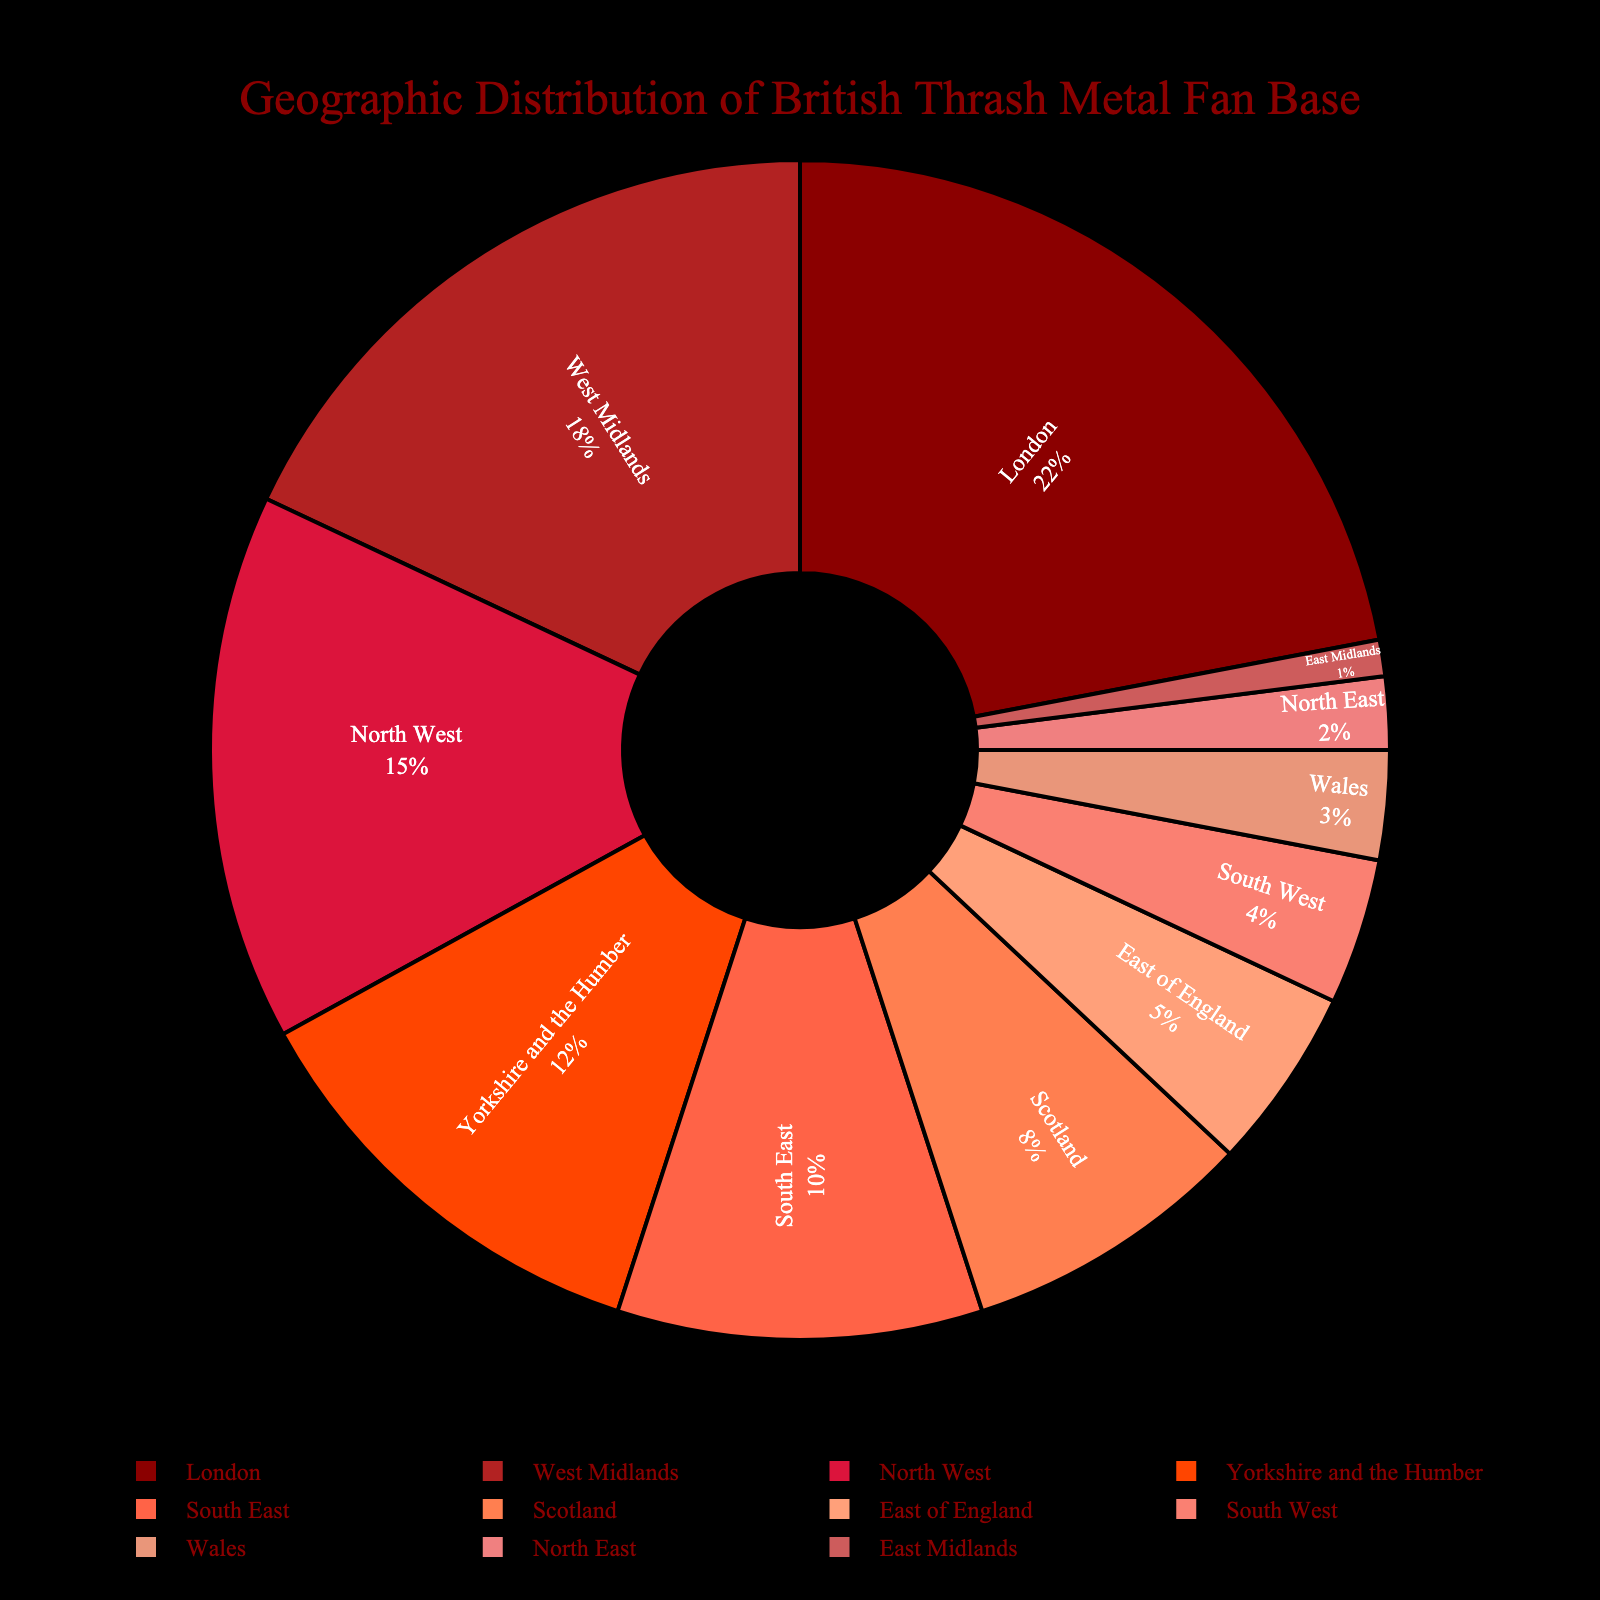What is the region with the highest percentage of British Thrash Metal fans? The region with the highest percentage can be identified directly by looking for the largest segment in the pie chart. London has the biggest slice, indicating it has the highest percentage at 22%.
Answer: London Which two regions combined make up the largest percentage of the fan base? To find the combination that forms the largest percentage, identify the two largest slices in the pie chart. London (22%) and West Midlands (18%) have the biggest slices, summing up to 40%.
Answer: London and West Midlands How many regions have a fan base percentage of 10% or higher? By counting the slices that represent 10% or more, we have London (22%), West Midlands (18%), North West (15%), and Yorkshire and the Humber (12%). This sums to four regions.
Answer: Four What is the difference in fan base percentages between the region with the highest percentage and the region with the lowest percentage? The highest percentage is London at 22%, and the lowest is East Midlands at 1%. The difference is calculated as 22% - 1% = 21%.
Answer: 21% Name the regions that make up more than 15% of the fan base combined. Summarizing the relevant data: West Midlands (18%), North West (15%), and Yorkshire and the Humber (12%) each contribute less than 15% separately. London (22%) is the sole region surpassing this threshold.
Answer: London Which region contributes the smallest slice to the fan base, and what is its percentage? The smallest slice is the East Midlands, which has the smallest visible segment in the pie chart at 1%.
Answer: East Midlands Are there more regions with less than 5% fan base, or more than 5% fan base? Comparing the number of regions:
- Less than 5%: East of England (5%), South West (4%), Wales (3%), North East (2%), East Midlands (1%) – 5 regions
- More than 5%: London (22%), West Midlands (18%), North West (15%), Yorkshire and the Humber (12%), South East (10%), Scotland (8%) – 6 regions
Therefore, there are more regions with more than 5% fan base.
Answer: More than 5% fan base Which regions combined just make up 35% of the fan base? Summing regions to achieve 35%: North West (15%) + Yorkshire and the Humber (12%) + South East (10%) = 37%, which exceeds 35%. Adjusting, Yorkshire and the Humber (12%) + Scotland (8%) + East of England (5%) + South West (4%) + Wales (3%) + North East (2%) + East Midlands (1%) = 35%.
Answer: Yorkshire and the Humber, Scotland, East of England, South West, Wales, North East, and East Midlands What is the average fan base percentage for regions with more than 10%? Identifying the regions: London (22%), West Midlands (18%), North West (15%), Yorkshire and the Humber (12%). The average is calculated as (22 + 18 + 15 + 12) / 4 = 67 / 4 = 16.75%.
Answer: 16.75% 